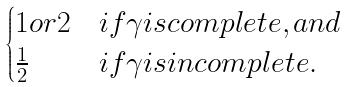Convert formula to latex. <formula><loc_0><loc_0><loc_500><loc_500>\begin{cases} 1 o r 2 & i f \gamma i s c o m p l e t e , a n d \\ \frac { 1 } { 2 } & i f \gamma i s i n c o m p l e t e . \\ \end{cases}</formula> 